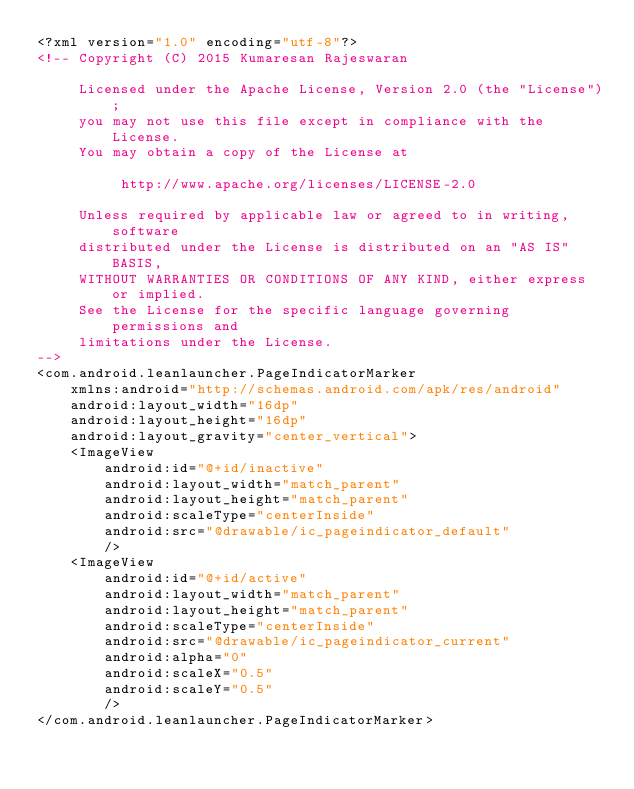<code> <loc_0><loc_0><loc_500><loc_500><_XML_><?xml version="1.0" encoding="utf-8"?>
<!-- Copyright (C) 2015 Kumaresan Rajeswaran

     Licensed under the Apache License, Version 2.0 (the "License");
     you may not use this file except in compliance with the License.
     You may obtain a copy of the License at

          http://www.apache.org/licenses/LICENSE-2.0

     Unless required by applicable law or agreed to in writing, software
     distributed under the License is distributed on an "AS IS" BASIS,
     WITHOUT WARRANTIES OR CONDITIONS OF ANY KIND, either express or implied.
     See the License for the specific language governing permissions and
     limitations under the License.
-->
<com.android.leanlauncher.PageIndicatorMarker
    xmlns:android="http://schemas.android.com/apk/res/android"
    android:layout_width="16dp"
    android:layout_height="16dp"
    android:layout_gravity="center_vertical">
    <ImageView
        android:id="@+id/inactive"
        android:layout_width="match_parent"
        android:layout_height="match_parent"
        android:scaleType="centerInside"
        android:src="@drawable/ic_pageindicator_default"
        />
    <ImageView
        android:id="@+id/active"
        android:layout_width="match_parent"
        android:layout_height="match_parent"
        android:scaleType="centerInside"
        android:src="@drawable/ic_pageindicator_current"
        android:alpha="0"
        android:scaleX="0.5"
        android:scaleY="0.5"
        />
</com.android.leanlauncher.PageIndicatorMarker>
</code> 